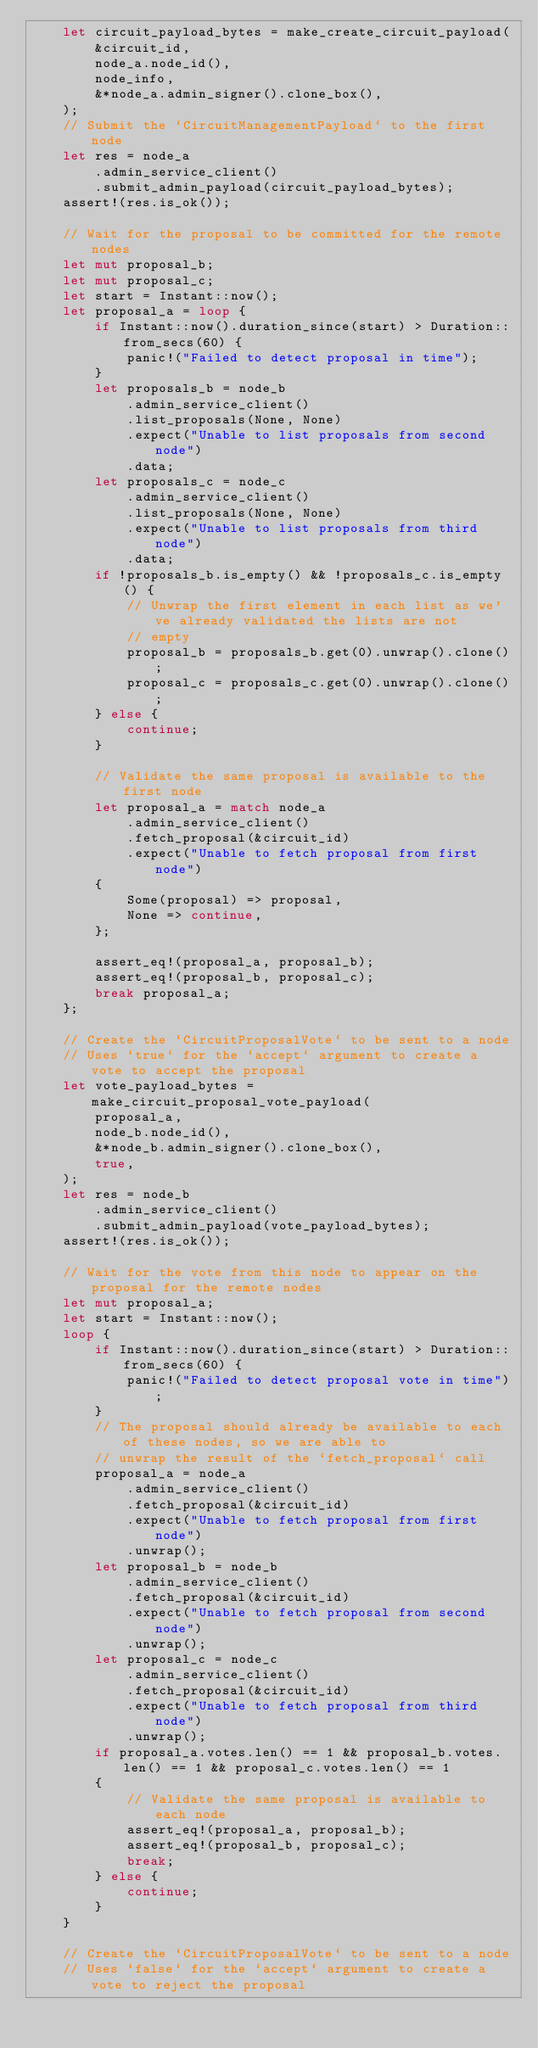Convert code to text. <code><loc_0><loc_0><loc_500><loc_500><_Rust_>    let circuit_payload_bytes = make_create_circuit_payload(
        &circuit_id,
        node_a.node_id(),
        node_info,
        &*node_a.admin_signer().clone_box(),
    );
    // Submit the `CircuitManagementPayload` to the first node
    let res = node_a
        .admin_service_client()
        .submit_admin_payload(circuit_payload_bytes);
    assert!(res.is_ok());

    // Wait for the proposal to be committed for the remote nodes
    let mut proposal_b;
    let mut proposal_c;
    let start = Instant::now();
    let proposal_a = loop {
        if Instant::now().duration_since(start) > Duration::from_secs(60) {
            panic!("Failed to detect proposal in time");
        }
        let proposals_b = node_b
            .admin_service_client()
            .list_proposals(None, None)
            .expect("Unable to list proposals from second node")
            .data;
        let proposals_c = node_c
            .admin_service_client()
            .list_proposals(None, None)
            .expect("Unable to list proposals from third node")
            .data;
        if !proposals_b.is_empty() && !proposals_c.is_empty() {
            // Unwrap the first element in each list as we've already validated the lists are not
            // empty
            proposal_b = proposals_b.get(0).unwrap().clone();
            proposal_c = proposals_c.get(0).unwrap().clone();
        } else {
            continue;
        }

        // Validate the same proposal is available to the first node
        let proposal_a = match node_a
            .admin_service_client()
            .fetch_proposal(&circuit_id)
            .expect("Unable to fetch proposal from first node")
        {
            Some(proposal) => proposal,
            None => continue,
        };

        assert_eq!(proposal_a, proposal_b);
        assert_eq!(proposal_b, proposal_c);
        break proposal_a;
    };

    // Create the `CircuitProposalVote` to be sent to a node
    // Uses `true` for the `accept` argument to create a vote to accept the proposal
    let vote_payload_bytes = make_circuit_proposal_vote_payload(
        proposal_a,
        node_b.node_id(),
        &*node_b.admin_signer().clone_box(),
        true,
    );
    let res = node_b
        .admin_service_client()
        .submit_admin_payload(vote_payload_bytes);
    assert!(res.is_ok());

    // Wait for the vote from this node to appear on the proposal for the remote nodes
    let mut proposal_a;
    let start = Instant::now();
    loop {
        if Instant::now().duration_since(start) > Duration::from_secs(60) {
            panic!("Failed to detect proposal vote in time");
        }
        // The proposal should already be available to each of these nodes, so we are able to
        // unwrap the result of the `fetch_proposal` call
        proposal_a = node_a
            .admin_service_client()
            .fetch_proposal(&circuit_id)
            .expect("Unable to fetch proposal from first node")
            .unwrap();
        let proposal_b = node_b
            .admin_service_client()
            .fetch_proposal(&circuit_id)
            .expect("Unable to fetch proposal from second node")
            .unwrap();
        let proposal_c = node_c
            .admin_service_client()
            .fetch_proposal(&circuit_id)
            .expect("Unable to fetch proposal from third node")
            .unwrap();
        if proposal_a.votes.len() == 1 && proposal_b.votes.len() == 1 && proposal_c.votes.len() == 1
        {
            // Validate the same proposal is available to each node
            assert_eq!(proposal_a, proposal_b);
            assert_eq!(proposal_b, proposal_c);
            break;
        } else {
            continue;
        }
    }

    // Create the `CircuitProposalVote` to be sent to a node
    // Uses `false` for the `accept` argument to create a vote to reject the proposal</code> 